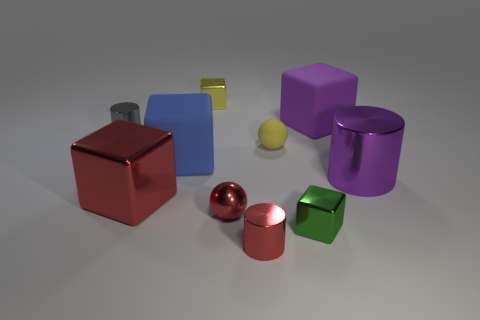Subtract all yellow cubes. How many cubes are left? 4 Subtract all cyan cubes. Subtract all yellow cylinders. How many cubes are left? 5 Subtract all cylinders. How many objects are left? 7 Subtract 1 red cylinders. How many objects are left? 9 Subtract all tiny blocks. Subtract all small balls. How many objects are left? 6 Add 5 big red things. How many big red things are left? 6 Add 8 small shiny cylinders. How many small shiny cylinders exist? 10 